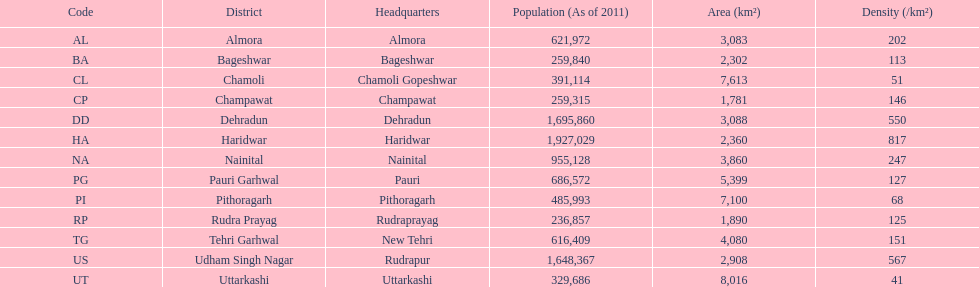How many total districts are there in this area? 13. 